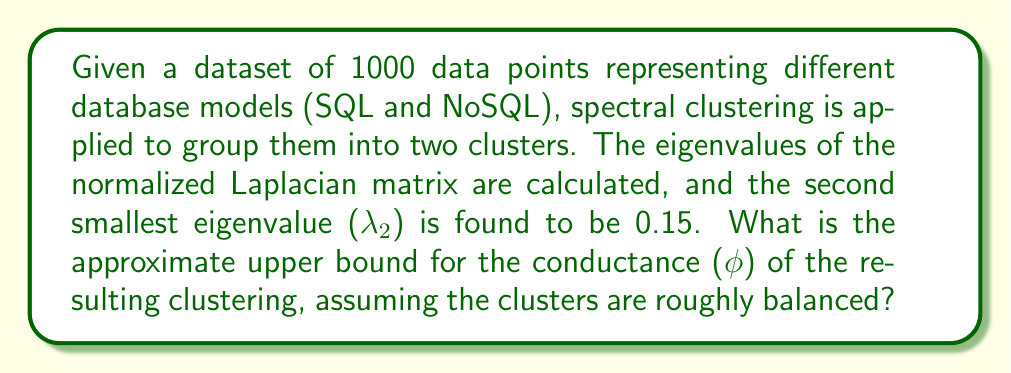Give your solution to this math problem. To solve this problem, we'll use Cheeger's inequality, which relates the conductance of a graph cut to the second smallest eigenvalue of the normalized Laplacian matrix. The steps are as follows:

1. Recall Cheeger's inequality:
   $$\frac{\lambda_2}{2} \leq \phi \leq \sqrt{2\lambda_2}$$
   where λ₂ is the second smallest eigenvalue of the normalized Laplacian, and ϕ is the conductance.

2. We are given that λ₂ = 0.15.

3. To find the upper bound for ϕ, we use the right side of the inequality:
   $$\phi \leq \sqrt{2\lambda_2}$$

4. Substitute the given value:
   $$\phi \leq \sqrt{2 \cdot 0.15}$$

5. Simplify:
   $$\phi \leq \sqrt{0.3}$$

6. Calculate the approximate value:
   $$\phi \leq 0.5477$$

Therefore, the approximate upper bound for the conductance of the resulting clustering is 0.5477.

This result suggests that the spectral clustering has produced a reasonably good separation between SQL and NoSQL database models, as a lower conductance indicates a better cut. For a database manager skeptical of NoSQL, this analysis shows that there are indeed discernible differences between SQL and NoSQL models, which may warrant further investigation into their respective properties, including ACID compliance.
Answer: $\phi \leq 0.5477$ 